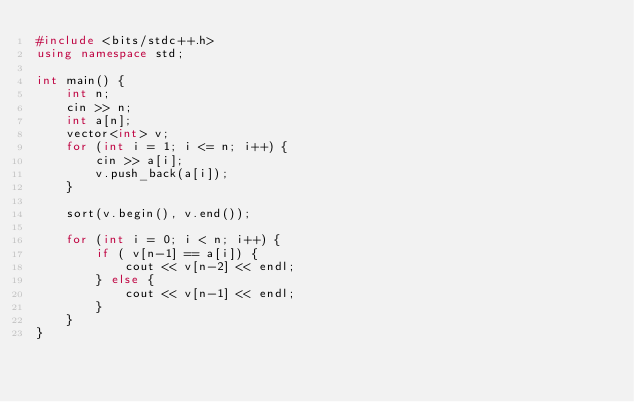Convert code to text. <code><loc_0><loc_0><loc_500><loc_500><_C++_>#include <bits/stdc++.h>
using namespace std;

int main() {
    int n;
    cin >> n;
    int a[n];
    vector<int> v;
    for (int i = 1; i <= n; i++) {
        cin >> a[i];
        v.push_back(a[i]);
    }

    sort(v.begin(), v.end());
    
    for (int i = 0; i < n; i++) {
        if ( v[n-1] == a[i]) {
            cout << v[n-2] << endl;
        } else {
            cout << v[n-1] << endl;
        }
    }
}
</code> 